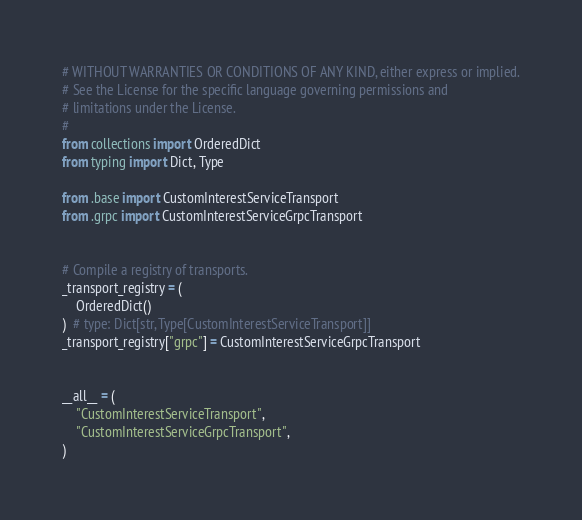Convert code to text. <code><loc_0><loc_0><loc_500><loc_500><_Python_># WITHOUT WARRANTIES OR CONDITIONS OF ANY KIND, either express or implied.
# See the License for the specific language governing permissions and
# limitations under the License.
#
from collections import OrderedDict
from typing import Dict, Type

from .base import CustomInterestServiceTransport
from .grpc import CustomInterestServiceGrpcTransport


# Compile a registry of transports.
_transport_registry = (
    OrderedDict()
)  # type: Dict[str, Type[CustomInterestServiceTransport]]
_transport_registry["grpc"] = CustomInterestServiceGrpcTransport


__all__ = (
    "CustomInterestServiceTransport",
    "CustomInterestServiceGrpcTransport",
)
</code> 